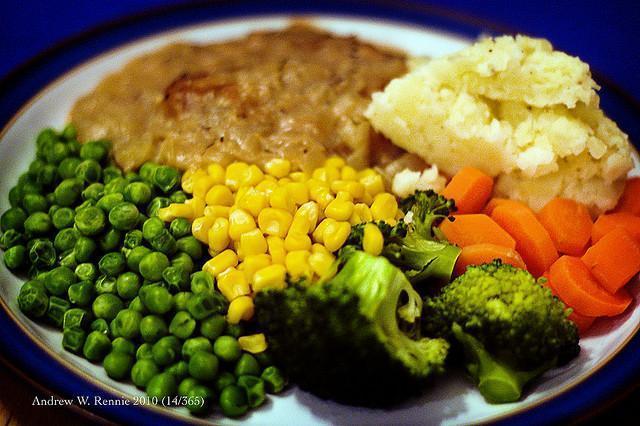How many broccolis are in the picture?
Give a very brief answer. 3. How many carrots are in the picture?
Give a very brief answer. 2. How many people are playing the game?
Give a very brief answer. 0. 